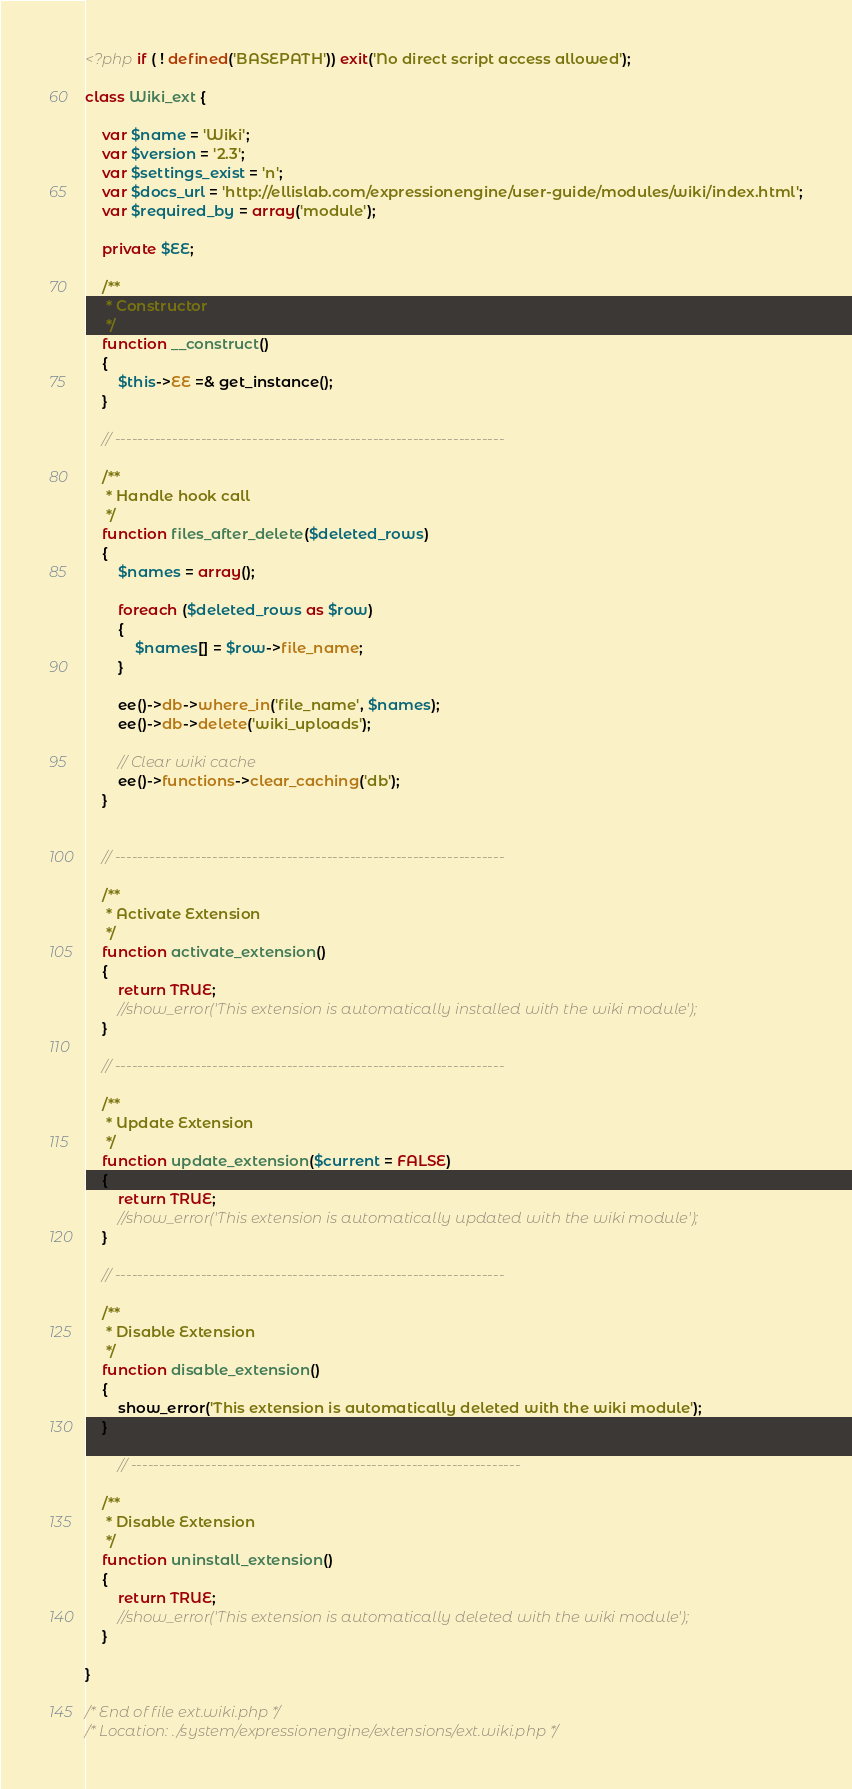<code> <loc_0><loc_0><loc_500><loc_500><_PHP_><?php if ( ! defined('BASEPATH')) exit('No direct script access allowed');

class Wiki_ext {

	var $name = 'Wiki';
	var $version = '2.3';
	var $settings_exist = 'n';
	var $docs_url = 'http://ellislab.com/expressionengine/user-guide/modules/wiki/index.html';
	var $required_by = array('module');

	private $EE;
	
	/**
	 * Constructor
	 */
	function __construct()
	{
		$this->EE =& get_instance();
	}

	// --------------------------------------------------------------------

	/**
	 * Handle hook call
	 */
	function files_after_delete($deleted_rows)
	{
		$names = array();
		
		foreach ($deleted_rows as $row)
		{
			$names[] = $row->file_name;
		}
		
		ee()->db->where_in('file_name', $names);
		ee()->db->delete('wiki_uploads');
							
		// Clear wiki cache
		ee()->functions->clear_caching('db');
	}
	

	// --------------------------------------------------------------------

	/**
	 * Activate Extension
	 */
	function activate_extension()
	{
		return TRUE;
		//show_error('This extension is automatically installed with the wiki module');
	}

	// --------------------------------------------------------------------

	/**
	 * Update Extension
	 */
	function update_extension($current = FALSE)
	{
		return TRUE;
		//show_error('This extension is automatically updated with the wiki module');
	}

	// --------------------------------------------------------------------

	/**
	 * Disable Extension
	 */
	function disable_extension()
	{
		show_error('This extension is automatically deleted with the wiki module');
	}
	
		// --------------------------------------------------------------------

	/**
	 * Disable Extension
	 */
	function uninstall_extension()
	{
		return TRUE;
		//show_error('This extension is automatically deleted with the wiki module');
	}
	
}

/* End of file ext.wiki.php */
/* Location: ./system/expressionengine/extensions/ext.wiki.php */</code> 